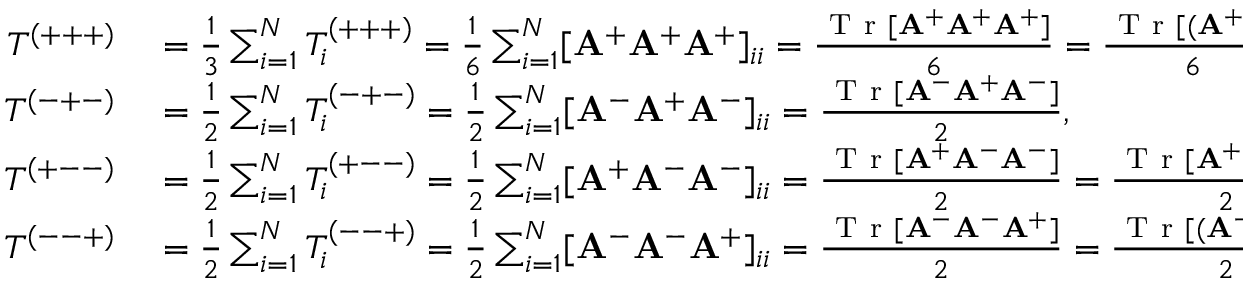<formula> <loc_0><loc_0><loc_500><loc_500>\begin{array} { r l } { T ^ { ( + + + ) } } & = \frac { 1 } { 3 } \sum _ { i = 1 } ^ { N } T _ { i } ^ { ( + + + ) } = \frac { 1 } { 6 } \sum _ { i = 1 } ^ { N } [ A ^ { + } A ^ { + } A ^ { + } ] _ { i i } = \frac { T r [ A ^ { + } A ^ { + } A ^ { + } ] } { 6 } = \frac { T r [ ( A ^ { + } ) ^ { 3 } ] } { 6 } , } \\ { T ^ { ( - + - ) } } & = \frac { 1 } { 2 } \sum _ { i = 1 } ^ { N } T _ { i } ^ { ( - + - ) } = \frac { 1 } { 2 } \sum _ { i = 1 } ^ { N } [ A ^ { - } A ^ { + } A ^ { - } ] _ { i i } = \frac { T r [ A ^ { - } A ^ { + } A ^ { - } ] } { 2 } , } \\ { T ^ { ( + - - ) } } & = \frac { 1 } { 2 } \sum _ { i = 1 } ^ { N } T _ { i } ^ { ( + - - ) } = \frac { 1 } { 2 } \sum _ { i = 1 } ^ { N } [ A ^ { + } \mathbf A ^ { - } A ^ { - } ] _ { i i } = \frac { T r [ A ^ { + } A ^ { - } A ^ { - } ] } { 2 } = \frac { T r [ A ^ { + } ( A ^ { - } ) ^ { 2 } ] } { 2 } , } \\ { T ^ { ( - - + ) } } & = \frac { 1 } { 2 } \sum _ { i = 1 } ^ { N } T _ { i } ^ { ( - - + ) } = \frac { 1 } { 2 } \sum _ { i = 1 } ^ { N } [ A ^ { - } A ^ { - } A ^ { + } ] _ { i i } = \frac { T r [ A ^ { - } \mathbf A ^ { - } A ^ { + } ] } { 2 } = \frac { T r [ ( A ^ { - } ) ^ { 2 } A ^ { + } ] } { 2 } ; } \end{array}</formula> 